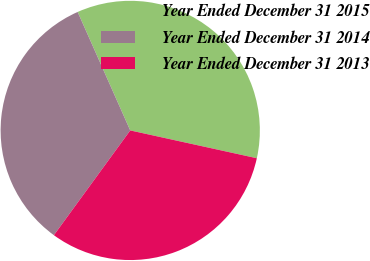<chart> <loc_0><loc_0><loc_500><loc_500><pie_chart><fcel>Year Ended December 31 2015<fcel>Year Ended December 31 2014<fcel>Year Ended December 31 2013<nl><fcel>35.09%<fcel>33.33%<fcel>31.58%<nl></chart> 